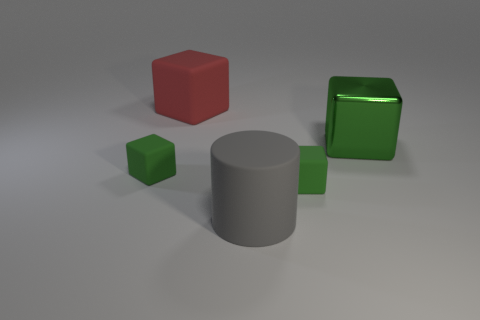Subtract all brown spheres. How many green blocks are left? 3 Subtract all blue cubes. Subtract all purple spheres. How many cubes are left? 4 Add 2 large red metallic blocks. How many objects exist? 7 Subtract all cylinders. How many objects are left? 4 Add 1 tiny things. How many tiny things exist? 3 Subtract 0 cyan cylinders. How many objects are left? 5 Subtract all big cyan shiny cylinders. Subtract all green rubber blocks. How many objects are left? 3 Add 1 large things. How many large things are left? 4 